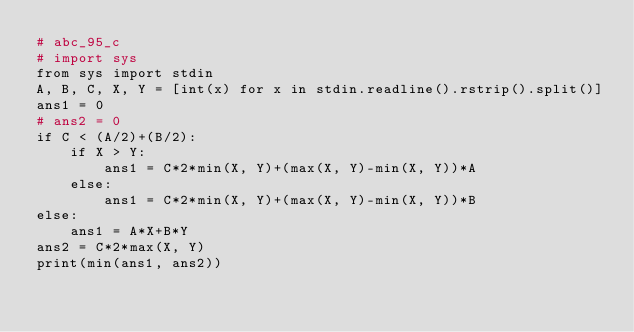Convert code to text. <code><loc_0><loc_0><loc_500><loc_500><_Python_># abc_95_c
# import sys
from sys import stdin
A, B, C, X, Y = [int(x) for x in stdin.readline().rstrip().split()]
ans1 = 0
# ans2 = 0
if C < (A/2)+(B/2):
    if X > Y:
        ans1 = C*2*min(X, Y)+(max(X, Y)-min(X, Y))*A
    else:
        ans1 = C*2*min(X, Y)+(max(X, Y)-min(X, Y))*B
else:
    ans1 = A*X+B*Y
ans2 = C*2*max(X, Y)
print(min(ans1, ans2))
</code> 